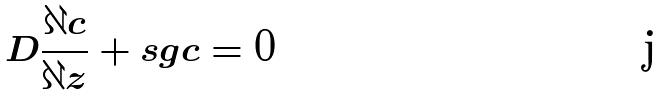Convert formula to latex. <formula><loc_0><loc_0><loc_500><loc_500>D \frac { \partial c } { \partial z } + s g c = 0</formula> 